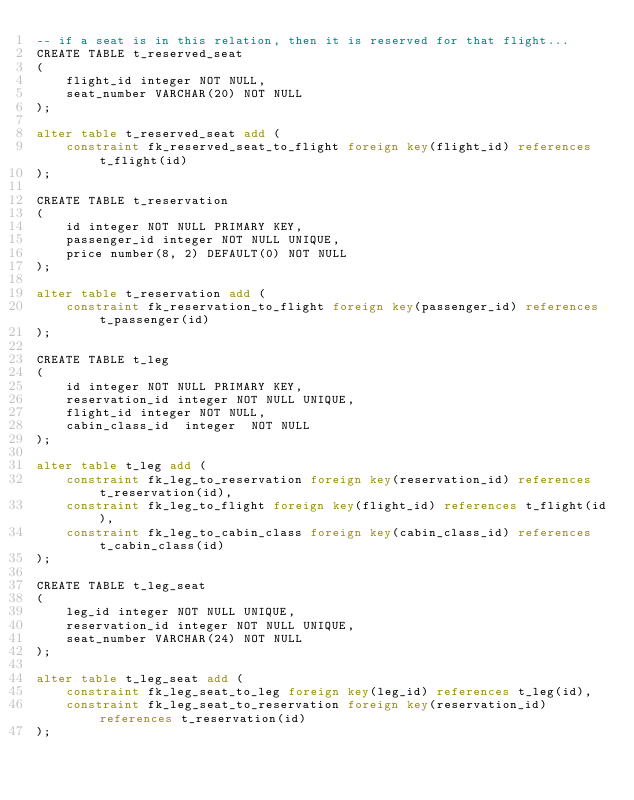Convert code to text. <code><loc_0><loc_0><loc_500><loc_500><_SQL_>-- if a seat is in this relation, then it is reserved for that flight...
CREATE TABLE t_reserved_seat
(
	flight_id integer NOT NULL,
	seat_number VARCHAR(20) NOT NULL
);

alter table t_reserved_seat add (
	constraint fk_reserved_seat_to_flight foreign key(flight_id) references t_flight(id)
);

CREATE TABLE t_reservation
(
	id integer NOT NULL PRIMARY KEY,
	passenger_id integer NOT NULL UNIQUE,
	price number(8, 2) DEFAULT(0) NOT NULL
);

alter table t_reservation add (
	constraint fk_reservation_to_flight foreign key(passenger_id) references t_passenger(id)
);

CREATE TABLE t_leg
(
	id integer NOT NULL PRIMARY KEY,
	reservation_id integer NOT NULL UNIQUE,
	flight_id integer NOT NULL,
	cabin_class_id  integer  NOT NULL
);

alter table t_leg add (
	constraint fk_leg_to_reservation foreign key(reservation_id) references t_reservation(id),
	constraint fk_leg_to_flight foreign key(flight_id) references t_flight(id),
	constraint fk_leg_to_cabin_class foreign key(cabin_class_id) references t_cabin_class(id)
);

CREATE TABLE t_leg_seat 
(
	leg_id integer NOT NULL UNIQUE,
	reservation_id integer NOT NULL UNIQUE,
	seat_number VARCHAR(24) NOT NULL
);

alter table t_leg_seat add (
	constraint fk_leg_seat_to_leg foreign key(leg_id) references t_leg(id),
	constraint fk_leg_seat_to_reservation foreign key(reservation_id) references t_reservation(id)
);
</code> 